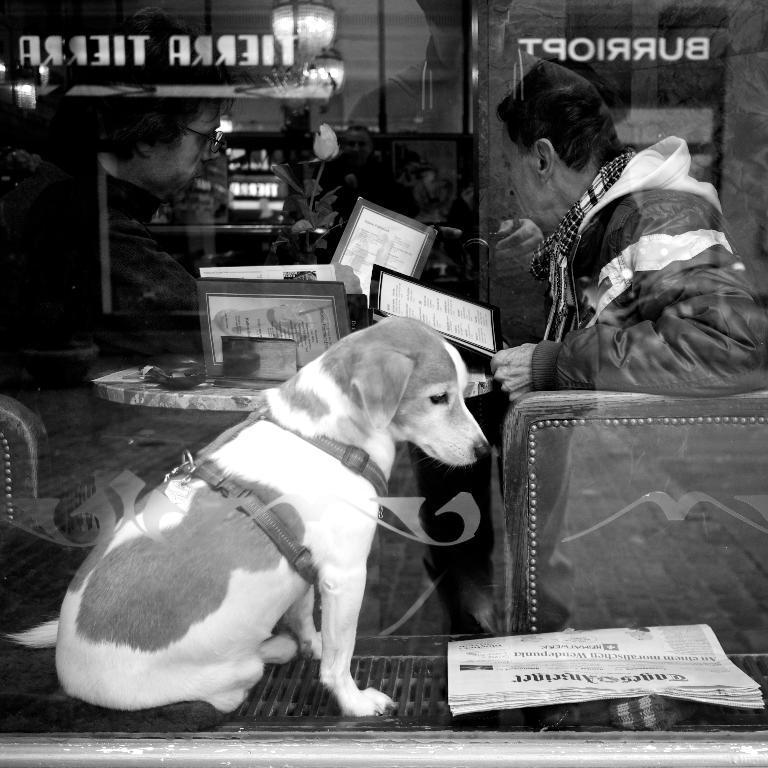Can you describe this image briefly? This is a black and white image. There is a chair on the right side and a person is sitting on it is holding someone book, a table is in front of him. There are so many books on the table, there are lights on the top and there is a dog in the middle which has belt, there is a newspaper in the bottom right corner. 